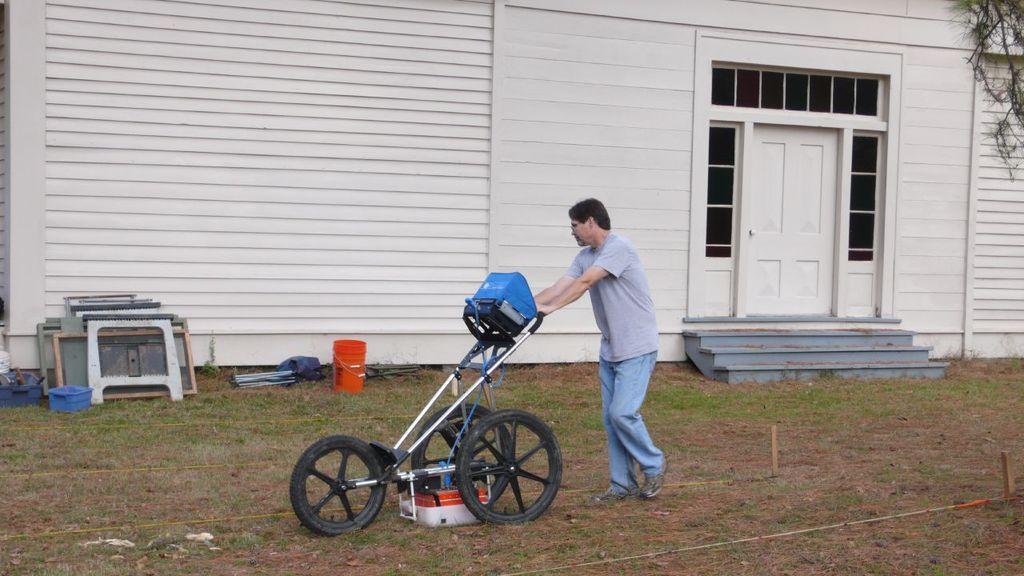In one or two sentences, can you explain what this image depicts? This picture consists of persons holding a trolley, building visible in the middle, in front of building there is a bucket , there are some metal stands and a blue color basket kept on floor, in the top right there are some leaves visible. 